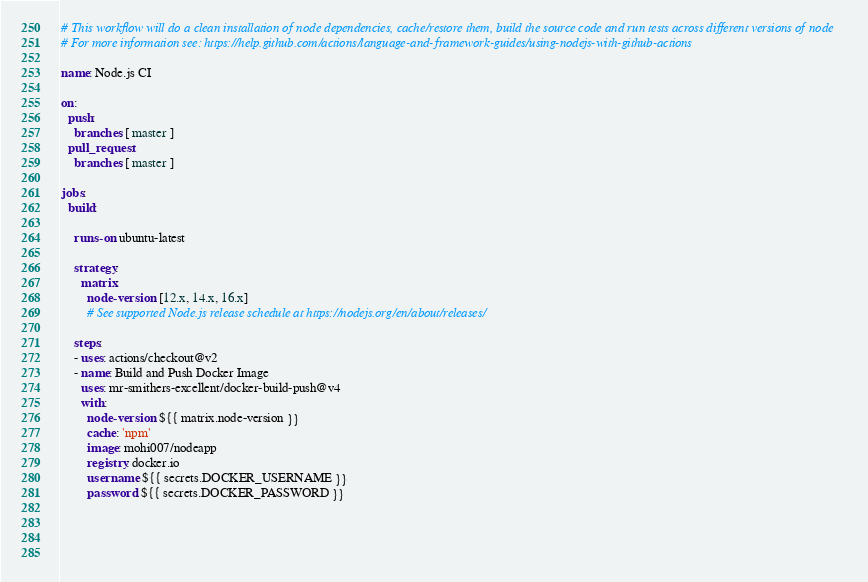<code> <loc_0><loc_0><loc_500><loc_500><_YAML_># This workflow will do a clean installation of node dependencies, cache/restore them, build the source code and run tests across different versions of node
# For more information see: https://help.github.com/actions/language-and-framework-guides/using-nodejs-with-github-actions

name: Node.js CI

on:
  push:
    branches: [ master ]
  pull_request:
    branches: [ master ]

jobs:
  build:

    runs-on: ubuntu-latest

    strategy:
      matrix:
        node-version: [12.x, 14.x, 16.x]
        # See supported Node.js release schedule at https://nodejs.org/en/about/releases/

    steps:
    - uses: actions/checkout@v2
    - name: Build and Push Docker Image
      uses: mr-smithers-excellent/docker-build-push@v4
      with:
        node-version: ${{ matrix.node-version }}
        cache: 'npm'
        image: mohi007/nodeapp
        registry: docker.io
        username: ${{ secrets.DOCKER_USERNAME }}
        password: ${{ secrets.DOCKER_PASSWORD }}
 
    

  
</code> 